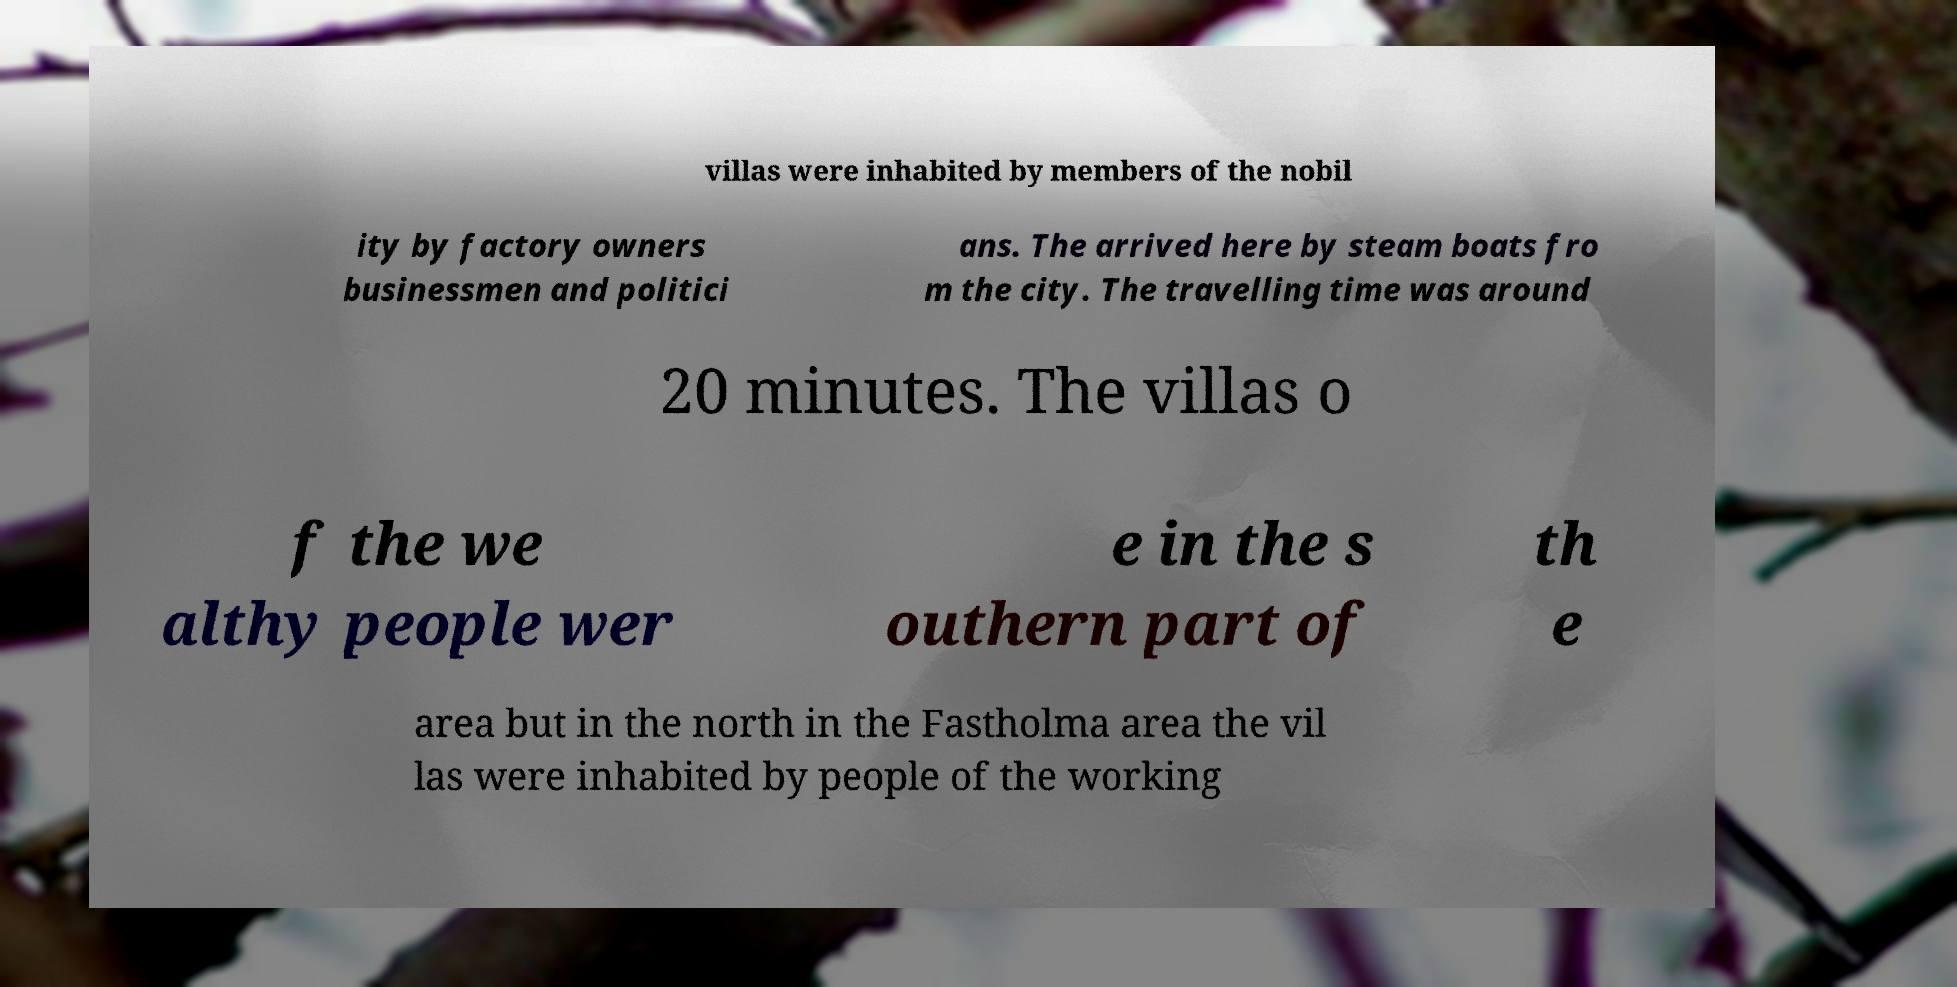Can you read and provide the text displayed in the image?This photo seems to have some interesting text. Can you extract and type it out for me? villas were inhabited by members of the nobil ity by factory owners businessmen and politici ans. The arrived here by steam boats fro m the city. The travelling time was around 20 minutes. The villas o f the we althy people wer e in the s outhern part of th e area but in the north in the Fastholma area the vil las were inhabited by people of the working 